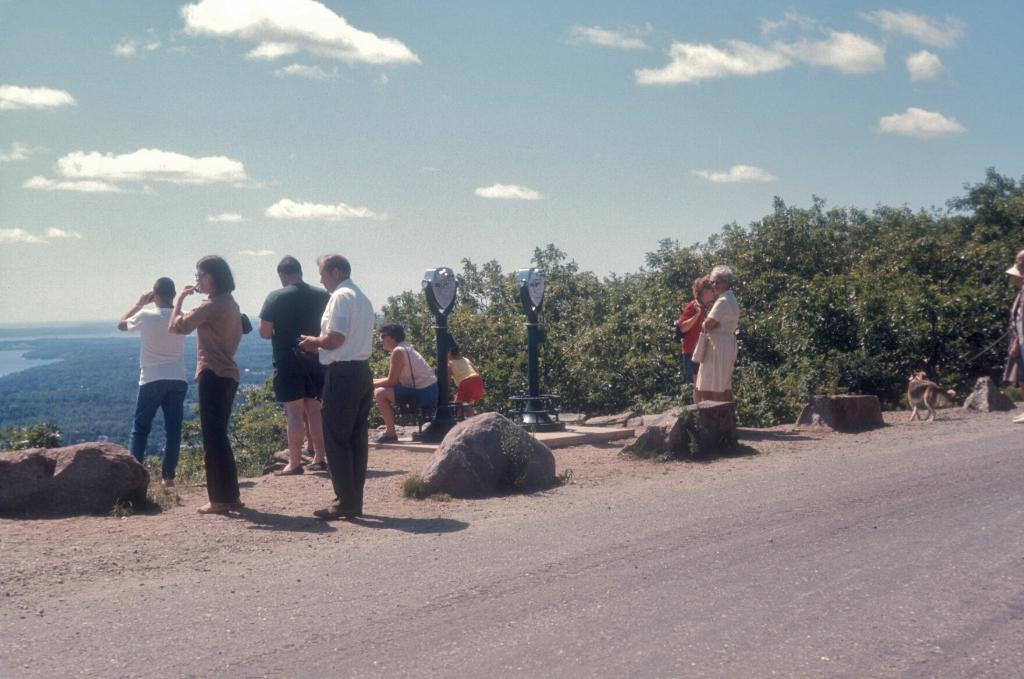How many people are visible in the image? There are many people in the image. What is located at the bottom of the image? There is a road at the bottom of the image. What can be seen to the right of the image? There are plants to the right of the image. What is visible in the sky in the background? There are clouds in the sky in the background. What is located to the left of the image? There is an ocean to the left of the image. Can you tell me how many fans are visible in the image? There are no fans present in the image. Is there a rifle being used by any of the people in the image? There is no rifle visible in the image; only people, a road, plants, clouds, and an ocean are present. 